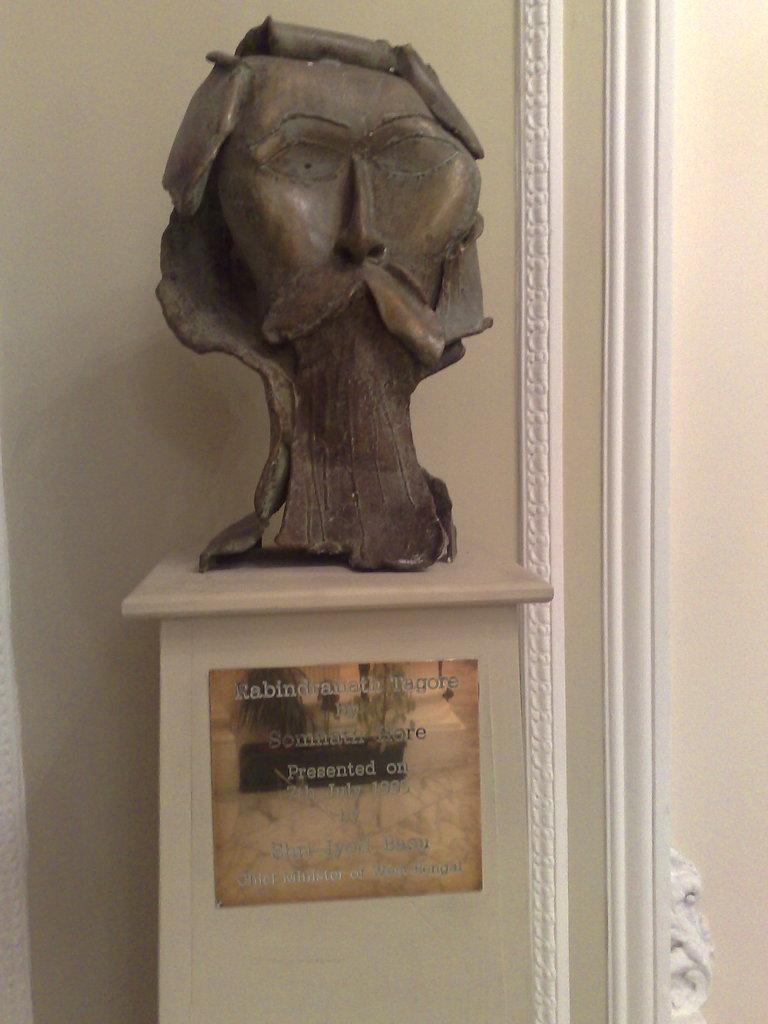What is the main subject in the center of the image? There is a statue in the center of the image. What can be seen in the background of the image? There is a wall in the background of the image. Reasoning: Let's think step by step by step in order to produce the conversation. We start by identifying the main subject in the image, which is the statue. Then, we expand the conversation to include the background of the image, which features a wall. Each question is designed to elicit a specific detail about the image that is known from the provided facts. Absurd Question/Answer: How many dogs are present in the image? There are no dogs present in the image; it only features a statue and a wall. What day of the week is depicted in the image? The image does not depict a specific day of the week; it is a still image of a statue and a wall. What type of glass is used to create the statue in the image? There is no mention of glass being used to create the statue in the image; it is a solid structure. 